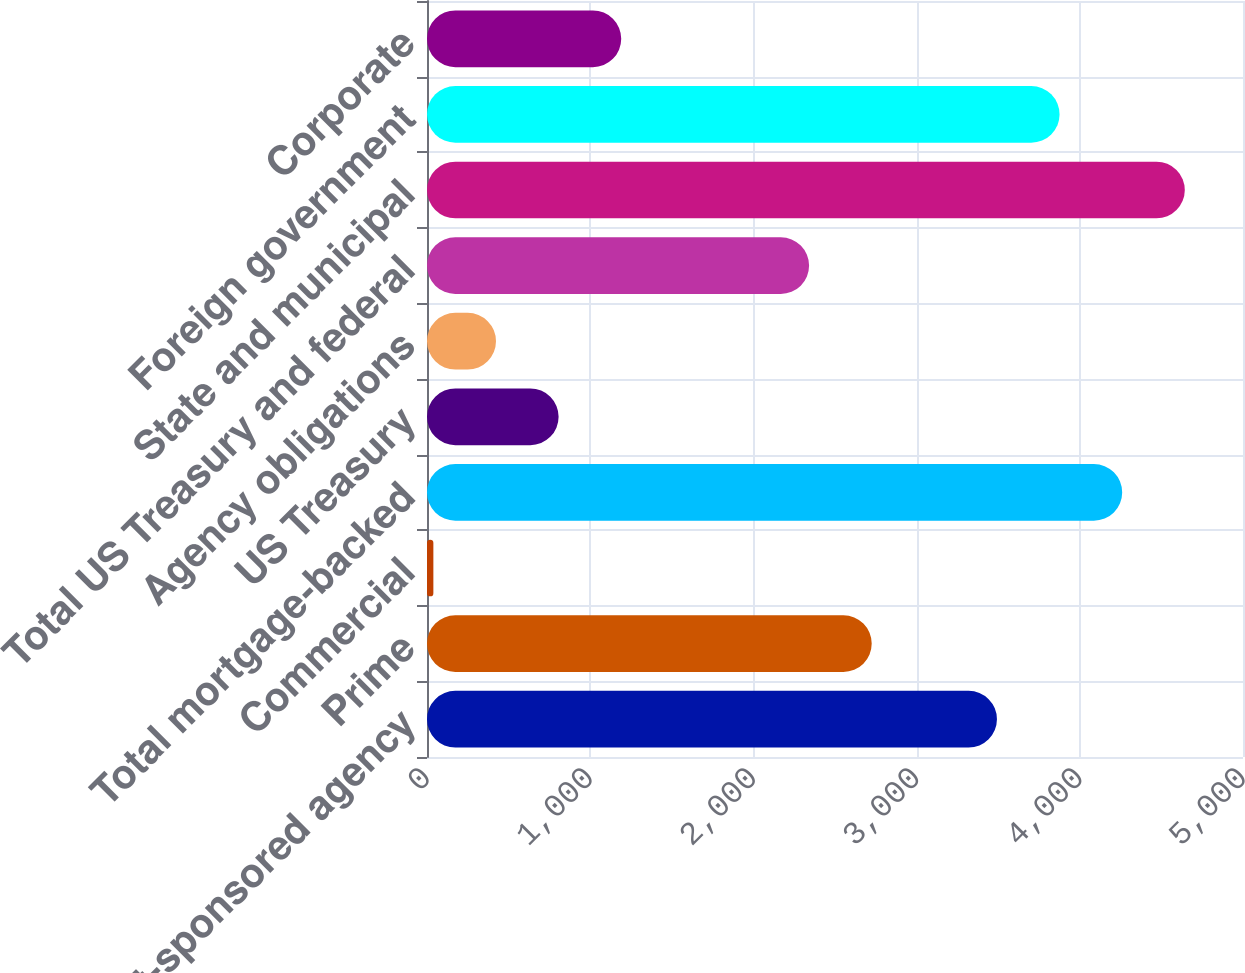<chart> <loc_0><loc_0><loc_500><loc_500><bar_chart><fcel>US government-sponsored agency<fcel>Prime<fcel>Commercial<fcel>Total mortgage-backed<fcel>US Treasury<fcel>Agency obligations<fcel>Total US Treasury and federal<fcel>State and municipal<fcel>Foreign government<fcel>Corporate<nl><fcel>3492.3<fcel>2724.9<fcel>39<fcel>4259.7<fcel>806.4<fcel>422.7<fcel>2341.2<fcel>4643.4<fcel>3876<fcel>1190.1<nl></chart> 